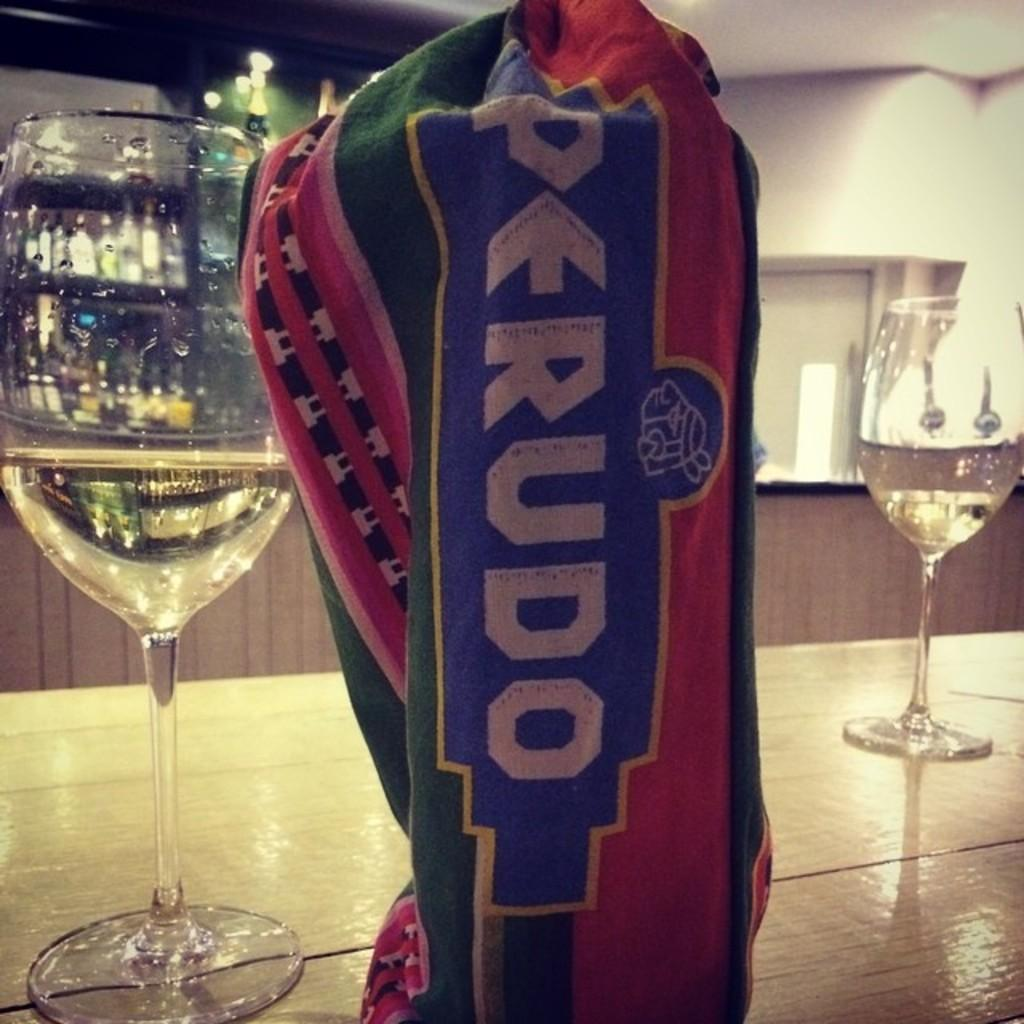<image>
Summarize the visual content of the image. A countertop with a couple of wine glasses and a coloful Perudo cloth bag. 